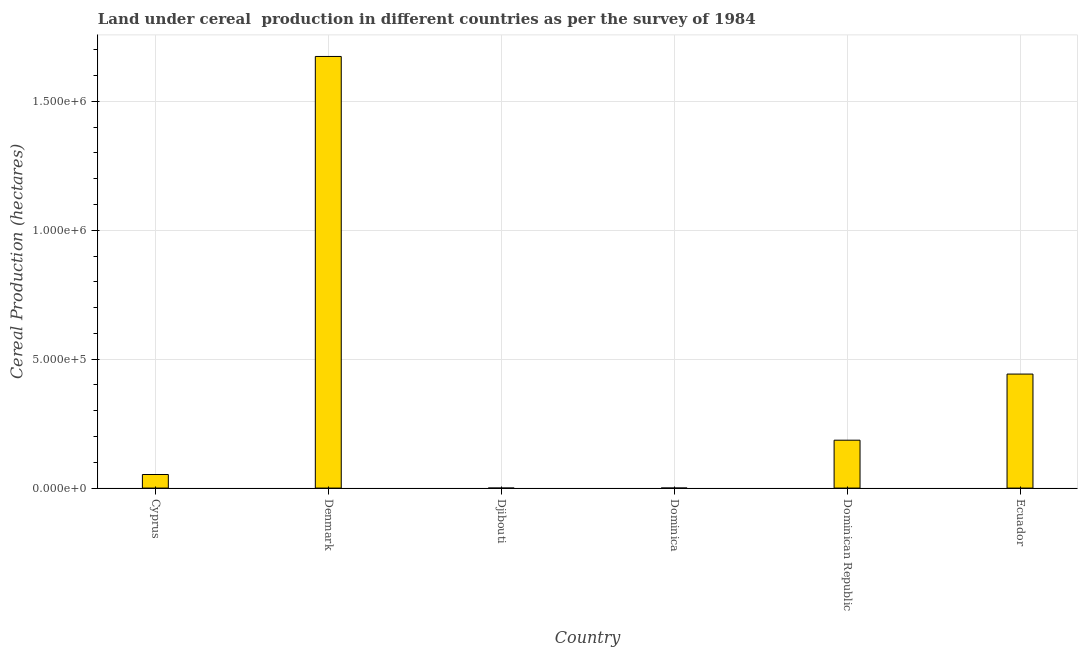Does the graph contain any zero values?
Make the answer very short. No. Does the graph contain grids?
Provide a succinct answer. Yes. What is the title of the graph?
Provide a succinct answer. Land under cereal  production in different countries as per the survey of 1984. What is the label or title of the X-axis?
Ensure brevity in your answer.  Country. What is the label or title of the Y-axis?
Make the answer very short. Cereal Production (hectares). What is the land under cereal production in Cyprus?
Keep it short and to the point. 5.27e+04. Across all countries, what is the maximum land under cereal production?
Offer a very short reply. 1.67e+06. In which country was the land under cereal production minimum?
Give a very brief answer. Djibouti. What is the sum of the land under cereal production?
Make the answer very short. 2.36e+06. What is the difference between the land under cereal production in Denmark and Ecuador?
Your response must be concise. 1.23e+06. What is the average land under cereal production per country?
Your answer should be very brief. 3.93e+05. What is the median land under cereal production?
Offer a terse response. 1.19e+05. What is the ratio of the land under cereal production in Dominican Republic to that in Ecuador?
Make the answer very short. 0.42. Is the land under cereal production in Cyprus less than that in Dominican Republic?
Give a very brief answer. Yes. What is the difference between the highest and the second highest land under cereal production?
Provide a short and direct response. 1.23e+06. Is the sum of the land under cereal production in Djibouti and Ecuador greater than the maximum land under cereal production across all countries?
Ensure brevity in your answer.  No. What is the difference between the highest and the lowest land under cereal production?
Your answer should be compact. 1.67e+06. In how many countries, is the land under cereal production greater than the average land under cereal production taken over all countries?
Your answer should be very brief. 2. Are all the bars in the graph horizontal?
Your answer should be compact. No. How many countries are there in the graph?
Make the answer very short. 6. What is the Cereal Production (hectares) of Cyprus?
Your response must be concise. 5.27e+04. What is the Cereal Production (hectares) in Denmark?
Keep it short and to the point. 1.67e+06. What is the Cereal Production (hectares) of Dominica?
Your answer should be compact. 170. What is the Cereal Production (hectares) of Dominican Republic?
Your answer should be compact. 1.86e+05. What is the Cereal Production (hectares) of Ecuador?
Give a very brief answer. 4.42e+05. What is the difference between the Cereal Production (hectares) in Cyprus and Denmark?
Your answer should be very brief. -1.62e+06. What is the difference between the Cereal Production (hectares) in Cyprus and Djibouti?
Your answer should be compact. 5.27e+04. What is the difference between the Cereal Production (hectares) in Cyprus and Dominica?
Your answer should be compact. 5.25e+04. What is the difference between the Cereal Production (hectares) in Cyprus and Dominican Republic?
Make the answer very short. -1.33e+05. What is the difference between the Cereal Production (hectares) in Cyprus and Ecuador?
Ensure brevity in your answer.  -3.90e+05. What is the difference between the Cereal Production (hectares) in Denmark and Djibouti?
Ensure brevity in your answer.  1.67e+06. What is the difference between the Cereal Production (hectares) in Denmark and Dominica?
Make the answer very short. 1.67e+06. What is the difference between the Cereal Production (hectares) in Denmark and Dominican Republic?
Offer a very short reply. 1.49e+06. What is the difference between the Cereal Production (hectares) in Denmark and Ecuador?
Ensure brevity in your answer.  1.23e+06. What is the difference between the Cereal Production (hectares) in Djibouti and Dominica?
Your answer should be compact. -167. What is the difference between the Cereal Production (hectares) in Djibouti and Dominican Republic?
Offer a very short reply. -1.86e+05. What is the difference between the Cereal Production (hectares) in Djibouti and Ecuador?
Keep it short and to the point. -4.42e+05. What is the difference between the Cereal Production (hectares) in Dominica and Dominican Republic?
Keep it short and to the point. -1.86e+05. What is the difference between the Cereal Production (hectares) in Dominica and Ecuador?
Ensure brevity in your answer.  -4.42e+05. What is the difference between the Cereal Production (hectares) in Dominican Republic and Ecuador?
Your response must be concise. -2.56e+05. What is the ratio of the Cereal Production (hectares) in Cyprus to that in Denmark?
Provide a short and direct response. 0.03. What is the ratio of the Cereal Production (hectares) in Cyprus to that in Djibouti?
Keep it short and to the point. 1.76e+04. What is the ratio of the Cereal Production (hectares) in Cyprus to that in Dominica?
Your response must be concise. 310.06. What is the ratio of the Cereal Production (hectares) in Cyprus to that in Dominican Republic?
Give a very brief answer. 0.28. What is the ratio of the Cereal Production (hectares) in Cyprus to that in Ecuador?
Make the answer very short. 0.12. What is the ratio of the Cereal Production (hectares) in Denmark to that in Djibouti?
Your response must be concise. 5.58e+05. What is the ratio of the Cereal Production (hectares) in Denmark to that in Dominica?
Your response must be concise. 9847.69. What is the ratio of the Cereal Production (hectares) in Denmark to that in Dominican Republic?
Keep it short and to the point. 9.01. What is the ratio of the Cereal Production (hectares) in Denmark to that in Ecuador?
Offer a terse response. 3.79. What is the ratio of the Cereal Production (hectares) in Djibouti to that in Dominica?
Provide a short and direct response. 0.02. What is the ratio of the Cereal Production (hectares) in Djibouti to that in Ecuador?
Your response must be concise. 0. What is the ratio of the Cereal Production (hectares) in Dominica to that in Dominican Republic?
Your response must be concise. 0. What is the ratio of the Cereal Production (hectares) in Dominica to that in Ecuador?
Give a very brief answer. 0. What is the ratio of the Cereal Production (hectares) in Dominican Republic to that in Ecuador?
Your answer should be compact. 0.42. 